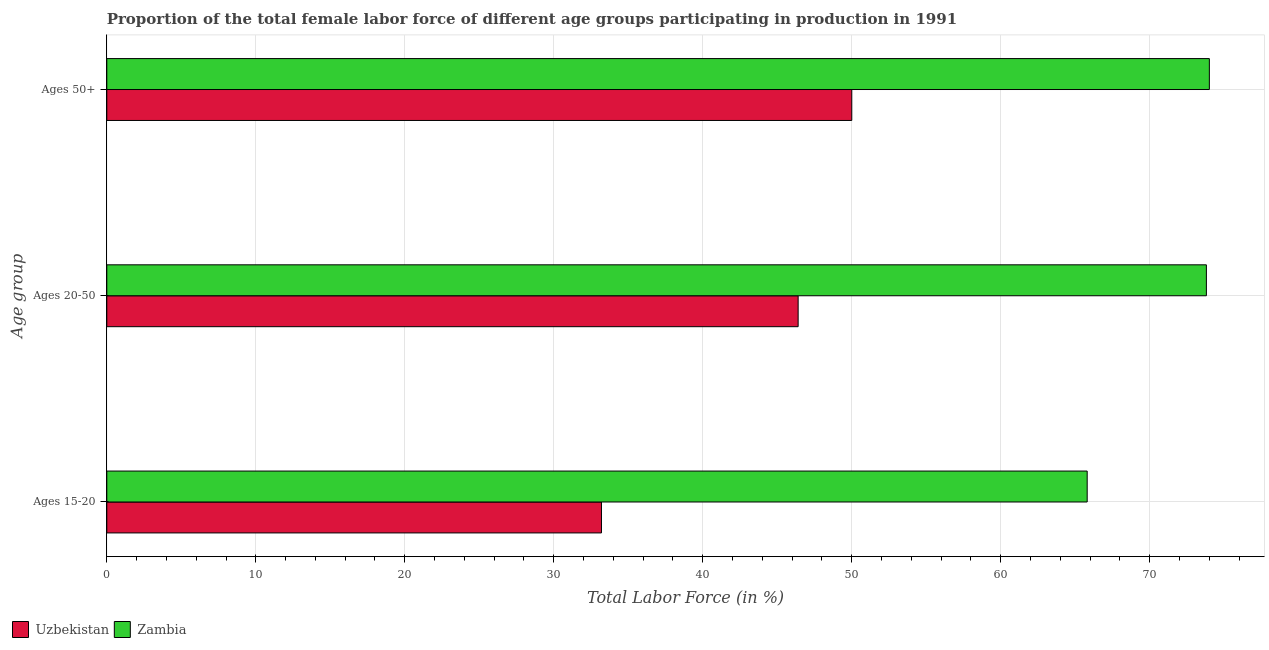How many different coloured bars are there?
Your response must be concise. 2. How many groups of bars are there?
Provide a short and direct response. 3. Are the number of bars per tick equal to the number of legend labels?
Your answer should be very brief. Yes. How many bars are there on the 1st tick from the bottom?
Ensure brevity in your answer.  2. What is the label of the 3rd group of bars from the top?
Make the answer very short. Ages 15-20. What is the percentage of female labor force within the age group 20-50 in Uzbekistan?
Offer a terse response. 46.4. Across all countries, what is the minimum percentage of female labor force within the age group 15-20?
Your response must be concise. 33.2. In which country was the percentage of female labor force within the age group 20-50 maximum?
Offer a terse response. Zambia. In which country was the percentage of female labor force above age 50 minimum?
Ensure brevity in your answer.  Uzbekistan. What is the total percentage of female labor force above age 50 in the graph?
Your answer should be compact. 124. What is the difference between the percentage of female labor force within the age group 20-50 in Uzbekistan and that in Zambia?
Ensure brevity in your answer.  -27.4. What is the difference between the percentage of female labor force within the age group 15-20 in Zambia and the percentage of female labor force above age 50 in Uzbekistan?
Offer a terse response. 15.8. What is the difference between the percentage of female labor force above age 50 and percentage of female labor force within the age group 15-20 in Zambia?
Keep it short and to the point. 8.2. What is the ratio of the percentage of female labor force above age 50 in Zambia to that in Uzbekistan?
Offer a very short reply. 1.48. What is the difference between the highest and the second highest percentage of female labor force within the age group 20-50?
Offer a terse response. 27.4. What is the difference between the highest and the lowest percentage of female labor force above age 50?
Your answer should be very brief. 24. Is the sum of the percentage of female labor force within the age group 15-20 in Zambia and Uzbekistan greater than the maximum percentage of female labor force above age 50 across all countries?
Offer a very short reply. Yes. What does the 2nd bar from the top in Ages 15-20 represents?
Keep it short and to the point. Uzbekistan. What does the 1st bar from the bottom in Ages 50+ represents?
Make the answer very short. Uzbekistan. Is it the case that in every country, the sum of the percentage of female labor force within the age group 15-20 and percentage of female labor force within the age group 20-50 is greater than the percentage of female labor force above age 50?
Offer a very short reply. Yes. How many bars are there?
Ensure brevity in your answer.  6. Are all the bars in the graph horizontal?
Your response must be concise. Yes. How are the legend labels stacked?
Keep it short and to the point. Horizontal. What is the title of the graph?
Offer a terse response. Proportion of the total female labor force of different age groups participating in production in 1991. Does "Lithuania" appear as one of the legend labels in the graph?
Provide a succinct answer. No. What is the label or title of the Y-axis?
Provide a succinct answer. Age group. What is the Total Labor Force (in %) in Uzbekistan in Ages 15-20?
Provide a succinct answer. 33.2. What is the Total Labor Force (in %) in Zambia in Ages 15-20?
Your response must be concise. 65.8. What is the Total Labor Force (in %) in Uzbekistan in Ages 20-50?
Your answer should be very brief. 46.4. What is the Total Labor Force (in %) in Zambia in Ages 20-50?
Keep it short and to the point. 73.8. What is the Total Labor Force (in %) of Uzbekistan in Ages 50+?
Your response must be concise. 50. What is the Total Labor Force (in %) in Zambia in Ages 50+?
Offer a very short reply. 74. Across all Age group, what is the maximum Total Labor Force (in %) of Zambia?
Give a very brief answer. 74. Across all Age group, what is the minimum Total Labor Force (in %) in Uzbekistan?
Your answer should be compact. 33.2. Across all Age group, what is the minimum Total Labor Force (in %) in Zambia?
Offer a very short reply. 65.8. What is the total Total Labor Force (in %) in Uzbekistan in the graph?
Offer a terse response. 129.6. What is the total Total Labor Force (in %) of Zambia in the graph?
Your answer should be very brief. 213.6. What is the difference between the Total Labor Force (in %) in Uzbekistan in Ages 15-20 and that in Ages 20-50?
Ensure brevity in your answer.  -13.2. What is the difference between the Total Labor Force (in %) in Zambia in Ages 15-20 and that in Ages 20-50?
Make the answer very short. -8. What is the difference between the Total Labor Force (in %) in Uzbekistan in Ages 15-20 and that in Ages 50+?
Make the answer very short. -16.8. What is the difference between the Total Labor Force (in %) of Uzbekistan in Ages 20-50 and that in Ages 50+?
Offer a terse response. -3.6. What is the difference between the Total Labor Force (in %) in Uzbekistan in Ages 15-20 and the Total Labor Force (in %) in Zambia in Ages 20-50?
Offer a terse response. -40.6. What is the difference between the Total Labor Force (in %) in Uzbekistan in Ages 15-20 and the Total Labor Force (in %) in Zambia in Ages 50+?
Give a very brief answer. -40.8. What is the difference between the Total Labor Force (in %) in Uzbekistan in Ages 20-50 and the Total Labor Force (in %) in Zambia in Ages 50+?
Provide a succinct answer. -27.6. What is the average Total Labor Force (in %) of Uzbekistan per Age group?
Your answer should be very brief. 43.2. What is the average Total Labor Force (in %) of Zambia per Age group?
Provide a succinct answer. 71.2. What is the difference between the Total Labor Force (in %) of Uzbekistan and Total Labor Force (in %) of Zambia in Ages 15-20?
Offer a terse response. -32.6. What is the difference between the Total Labor Force (in %) of Uzbekistan and Total Labor Force (in %) of Zambia in Ages 20-50?
Offer a terse response. -27.4. What is the difference between the Total Labor Force (in %) of Uzbekistan and Total Labor Force (in %) of Zambia in Ages 50+?
Offer a very short reply. -24. What is the ratio of the Total Labor Force (in %) of Uzbekistan in Ages 15-20 to that in Ages 20-50?
Offer a very short reply. 0.72. What is the ratio of the Total Labor Force (in %) of Zambia in Ages 15-20 to that in Ages 20-50?
Keep it short and to the point. 0.89. What is the ratio of the Total Labor Force (in %) of Uzbekistan in Ages 15-20 to that in Ages 50+?
Offer a terse response. 0.66. What is the ratio of the Total Labor Force (in %) of Zambia in Ages 15-20 to that in Ages 50+?
Keep it short and to the point. 0.89. What is the ratio of the Total Labor Force (in %) in Uzbekistan in Ages 20-50 to that in Ages 50+?
Provide a short and direct response. 0.93. What is the ratio of the Total Labor Force (in %) of Zambia in Ages 20-50 to that in Ages 50+?
Make the answer very short. 1. What is the difference between the highest and the second highest Total Labor Force (in %) of Uzbekistan?
Offer a very short reply. 3.6. What is the difference between the highest and the lowest Total Labor Force (in %) of Uzbekistan?
Make the answer very short. 16.8. What is the difference between the highest and the lowest Total Labor Force (in %) of Zambia?
Ensure brevity in your answer.  8.2. 